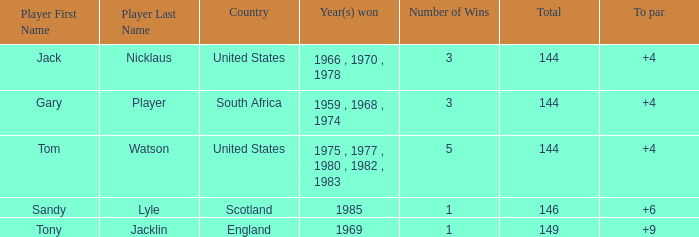What player had a To par smaller than 9 and won in 1985? Sandy Lyle. Parse the full table. {'header': ['Player First Name', 'Player Last Name', 'Country', 'Year(s) won', 'Number of Wins', 'Total', 'To par'], 'rows': [['Jack', 'Nicklaus', 'United States', '1966 , 1970 , 1978', '3', '144', '+4'], ['Gary', 'Player', 'South Africa', '1959 , 1968 , 1974', '3', '144', '+4'], ['Tom', 'Watson', 'United States', '1975 , 1977 , 1980 , 1982 , 1983', '5', '144', '+4'], ['Sandy', 'Lyle', 'Scotland', '1985', '1', '146', '+6'], ['Tony', 'Jacklin', 'England', '1969', '1', '149', '+9']]} 